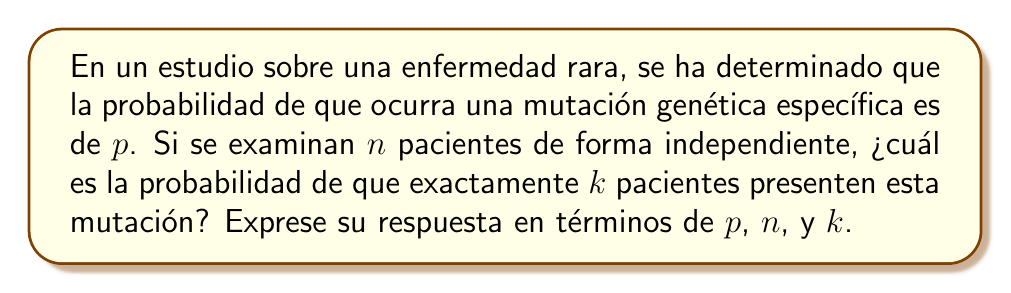Can you solve this math problem? Para resolver este problema, utilizaremos la distribución binomial, ya que estamos tratando con eventos independientes con dos posibles resultados (mutación o no mutación).

1) La probabilidad de que exactamente $k$ pacientes de $n$ presenten la mutación se expresa mediante la fórmula de la distribución binomial:

   $$P(X = k) = \binom{n}{k} p^k (1-p)^{n-k}$$

2) Donde:
   - $\binom{n}{k}$ es el coeficiente binomial, que representa el número de formas de elegir $k$ pacientes de $n$.
   - $p^k$ es la probabilidad de que $k$ pacientes tengan la mutación.
   - $(1-p)^{n-k}$ es la probabilidad de que los $n-k$ pacientes restantes no tengan la mutación.

3) El coeficiente binomial se calcula como:

   $$\binom{n}{k} = \frac{n!}{k!(n-k)!}$$

4) Sustituyendo esto en la fórmula original, obtenemos:

   $$P(X = k) = \frac{n!}{k!(n-k)!} p^k (1-p)^{n-k}$$

Esta expresión algebraica representa la probabilidad buscada en términos de $p$, $n$, y $k$.
Answer: $\frac{n!}{k!(n-k)!} p^k (1-p)^{n-k}$ 